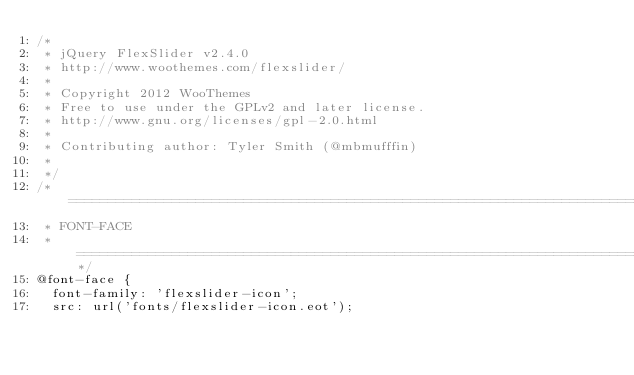<code> <loc_0><loc_0><loc_500><loc_500><_CSS_>/*
 * jQuery FlexSlider v2.4.0
 * http://www.woothemes.com/flexslider/
 *
 * Copyright 2012 WooThemes
 * Free to use under the GPLv2 and later license.
 * http://www.gnu.org/licenses/gpl-2.0.html
 *
 * Contributing author: Tyler Smith (@mbmufffin)
 * 
 */
/* ====================================================================================================================
 * FONT-FACE
 * ====================================================================================================================*/
@font-face {
  font-family: 'flexslider-icon';
  src: url('fonts/flexslider-icon.eot');</code> 